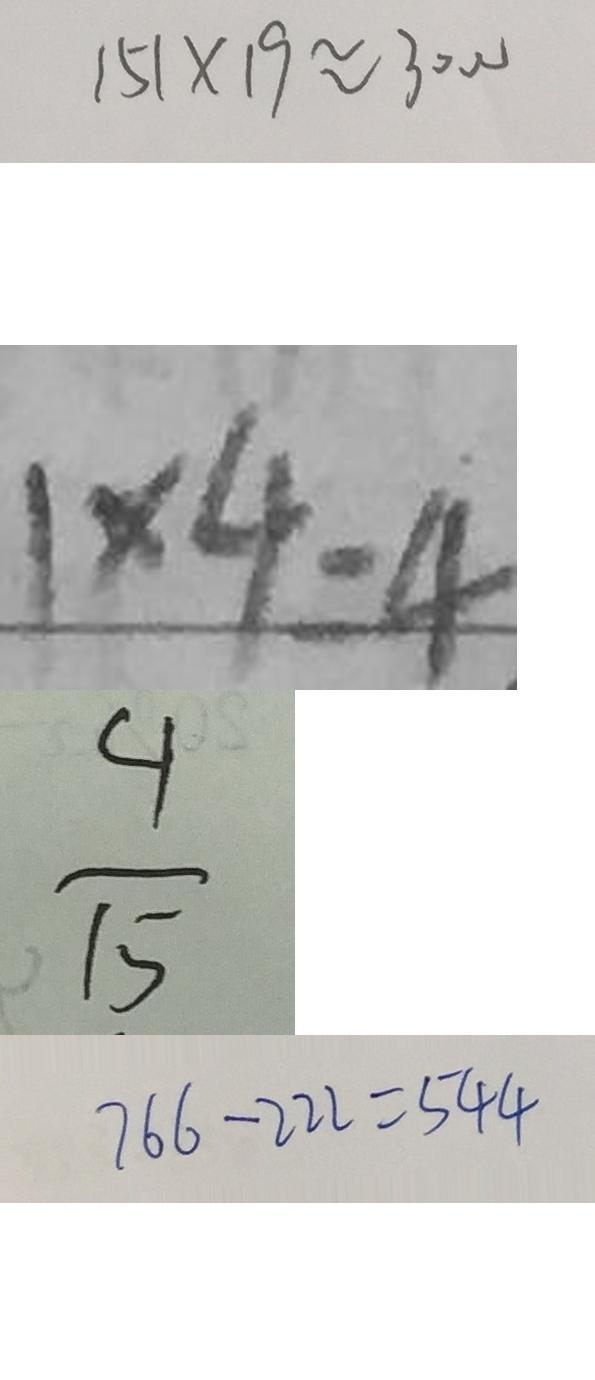Convert formula to latex. <formula><loc_0><loc_0><loc_500><loc_500>1 5 1 \times 1 9 \approx 3 0 0 0 
 1 \times 4 = 4 
 \frac { 4 } { 1 5 } 
 7 6 6 - 2 2 2 = 5 4 4</formula> 